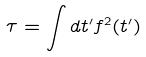<formula> <loc_0><loc_0><loc_500><loc_500>\tau = \int d t ^ { \prime } f ^ { 2 } ( t ^ { \prime } )</formula> 